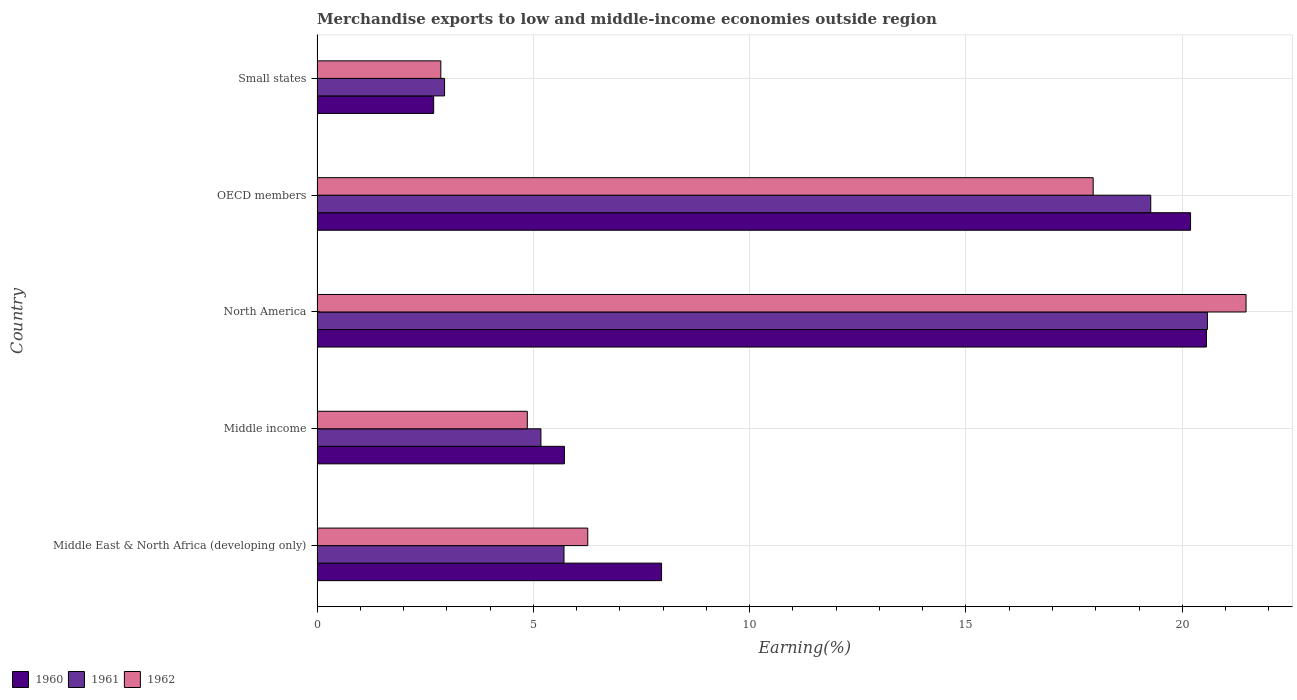How many different coloured bars are there?
Keep it short and to the point. 3. How many bars are there on the 3rd tick from the bottom?
Give a very brief answer. 3. What is the label of the 5th group of bars from the top?
Provide a short and direct response. Middle East & North Africa (developing only). In how many cases, is the number of bars for a given country not equal to the number of legend labels?
Offer a terse response. 0. What is the percentage of amount earned from merchandise exports in 1961 in Middle East & North Africa (developing only)?
Give a very brief answer. 5.71. Across all countries, what is the maximum percentage of amount earned from merchandise exports in 1961?
Your response must be concise. 20.58. Across all countries, what is the minimum percentage of amount earned from merchandise exports in 1962?
Make the answer very short. 2.86. In which country was the percentage of amount earned from merchandise exports in 1962 minimum?
Provide a succinct answer. Small states. What is the total percentage of amount earned from merchandise exports in 1960 in the graph?
Your response must be concise. 57.13. What is the difference between the percentage of amount earned from merchandise exports in 1961 in OECD members and that in Small states?
Your response must be concise. 16.32. What is the difference between the percentage of amount earned from merchandise exports in 1961 in Middle income and the percentage of amount earned from merchandise exports in 1962 in OECD members?
Keep it short and to the point. -12.77. What is the average percentage of amount earned from merchandise exports in 1962 per country?
Give a very brief answer. 10.68. What is the difference between the percentage of amount earned from merchandise exports in 1960 and percentage of amount earned from merchandise exports in 1961 in Middle East & North Africa (developing only)?
Make the answer very short. 2.26. What is the ratio of the percentage of amount earned from merchandise exports in 1962 in Middle East & North Africa (developing only) to that in OECD members?
Make the answer very short. 0.35. Is the percentage of amount earned from merchandise exports in 1960 in North America less than that in OECD members?
Make the answer very short. No. What is the difference between the highest and the second highest percentage of amount earned from merchandise exports in 1961?
Make the answer very short. 1.31. What is the difference between the highest and the lowest percentage of amount earned from merchandise exports in 1961?
Your answer should be very brief. 17.63. In how many countries, is the percentage of amount earned from merchandise exports in 1961 greater than the average percentage of amount earned from merchandise exports in 1961 taken over all countries?
Your answer should be very brief. 2. Is it the case that in every country, the sum of the percentage of amount earned from merchandise exports in 1960 and percentage of amount earned from merchandise exports in 1961 is greater than the percentage of amount earned from merchandise exports in 1962?
Keep it short and to the point. Yes. How many countries are there in the graph?
Ensure brevity in your answer.  5. What is the difference between two consecutive major ticks on the X-axis?
Your answer should be very brief. 5. Where does the legend appear in the graph?
Keep it short and to the point. Bottom left. What is the title of the graph?
Ensure brevity in your answer.  Merchandise exports to low and middle-income economies outside region. Does "2013" appear as one of the legend labels in the graph?
Offer a terse response. No. What is the label or title of the X-axis?
Ensure brevity in your answer.  Earning(%). What is the Earning(%) of 1960 in Middle East & North Africa (developing only)?
Offer a terse response. 7.96. What is the Earning(%) of 1961 in Middle East & North Africa (developing only)?
Give a very brief answer. 5.71. What is the Earning(%) in 1962 in Middle East & North Africa (developing only)?
Your answer should be compact. 6.26. What is the Earning(%) in 1960 in Middle income?
Your response must be concise. 5.72. What is the Earning(%) in 1961 in Middle income?
Offer a terse response. 5.17. What is the Earning(%) in 1962 in Middle income?
Offer a terse response. 4.86. What is the Earning(%) of 1960 in North America?
Give a very brief answer. 20.56. What is the Earning(%) in 1961 in North America?
Your answer should be compact. 20.58. What is the Earning(%) in 1962 in North America?
Keep it short and to the point. 21.47. What is the Earning(%) of 1960 in OECD members?
Your answer should be compact. 20.19. What is the Earning(%) of 1961 in OECD members?
Make the answer very short. 19.27. What is the Earning(%) of 1962 in OECD members?
Your answer should be very brief. 17.94. What is the Earning(%) of 1960 in Small states?
Your answer should be compact. 2.7. What is the Earning(%) of 1961 in Small states?
Offer a terse response. 2.95. What is the Earning(%) in 1962 in Small states?
Offer a very short reply. 2.86. Across all countries, what is the maximum Earning(%) in 1960?
Offer a very short reply. 20.56. Across all countries, what is the maximum Earning(%) in 1961?
Keep it short and to the point. 20.58. Across all countries, what is the maximum Earning(%) in 1962?
Offer a very short reply. 21.47. Across all countries, what is the minimum Earning(%) of 1960?
Offer a terse response. 2.7. Across all countries, what is the minimum Earning(%) of 1961?
Provide a succinct answer. 2.95. Across all countries, what is the minimum Earning(%) of 1962?
Keep it short and to the point. 2.86. What is the total Earning(%) of 1960 in the graph?
Your response must be concise. 57.13. What is the total Earning(%) of 1961 in the graph?
Keep it short and to the point. 53.68. What is the total Earning(%) of 1962 in the graph?
Your answer should be very brief. 53.39. What is the difference between the Earning(%) of 1960 in Middle East & North Africa (developing only) and that in Middle income?
Make the answer very short. 2.25. What is the difference between the Earning(%) of 1961 in Middle East & North Africa (developing only) and that in Middle income?
Your response must be concise. 0.53. What is the difference between the Earning(%) of 1962 in Middle East & North Africa (developing only) and that in Middle income?
Your answer should be very brief. 1.4. What is the difference between the Earning(%) in 1960 in Middle East & North Africa (developing only) and that in North America?
Offer a very short reply. -12.59. What is the difference between the Earning(%) of 1961 in Middle East & North Africa (developing only) and that in North America?
Give a very brief answer. -14.87. What is the difference between the Earning(%) in 1962 in Middle East & North Africa (developing only) and that in North America?
Ensure brevity in your answer.  -15.22. What is the difference between the Earning(%) of 1960 in Middle East & North Africa (developing only) and that in OECD members?
Keep it short and to the point. -12.23. What is the difference between the Earning(%) of 1961 in Middle East & North Africa (developing only) and that in OECD members?
Provide a short and direct response. -13.56. What is the difference between the Earning(%) in 1962 in Middle East & North Africa (developing only) and that in OECD members?
Provide a short and direct response. -11.68. What is the difference between the Earning(%) in 1960 in Middle East & North Africa (developing only) and that in Small states?
Offer a terse response. 5.27. What is the difference between the Earning(%) of 1961 in Middle East & North Africa (developing only) and that in Small states?
Give a very brief answer. 2.76. What is the difference between the Earning(%) of 1962 in Middle East & North Africa (developing only) and that in Small states?
Keep it short and to the point. 3.4. What is the difference between the Earning(%) in 1960 in Middle income and that in North America?
Provide a short and direct response. -14.84. What is the difference between the Earning(%) in 1961 in Middle income and that in North America?
Make the answer very short. -15.41. What is the difference between the Earning(%) of 1962 in Middle income and that in North America?
Ensure brevity in your answer.  -16.61. What is the difference between the Earning(%) of 1960 in Middle income and that in OECD members?
Provide a short and direct response. -14.47. What is the difference between the Earning(%) of 1961 in Middle income and that in OECD members?
Offer a very short reply. -14.1. What is the difference between the Earning(%) of 1962 in Middle income and that in OECD members?
Keep it short and to the point. -13.08. What is the difference between the Earning(%) of 1960 in Middle income and that in Small states?
Offer a very short reply. 3.02. What is the difference between the Earning(%) of 1961 in Middle income and that in Small states?
Give a very brief answer. 2.23. What is the difference between the Earning(%) of 1962 in Middle income and that in Small states?
Offer a terse response. 2. What is the difference between the Earning(%) of 1960 in North America and that in OECD members?
Offer a very short reply. 0.37. What is the difference between the Earning(%) of 1961 in North America and that in OECD members?
Your response must be concise. 1.31. What is the difference between the Earning(%) in 1962 in North America and that in OECD members?
Give a very brief answer. 3.53. What is the difference between the Earning(%) of 1960 in North America and that in Small states?
Provide a succinct answer. 17.86. What is the difference between the Earning(%) of 1961 in North America and that in Small states?
Your response must be concise. 17.63. What is the difference between the Earning(%) in 1962 in North America and that in Small states?
Offer a terse response. 18.61. What is the difference between the Earning(%) of 1960 in OECD members and that in Small states?
Offer a terse response. 17.5. What is the difference between the Earning(%) in 1961 in OECD members and that in Small states?
Make the answer very short. 16.32. What is the difference between the Earning(%) in 1962 in OECD members and that in Small states?
Provide a succinct answer. 15.08. What is the difference between the Earning(%) of 1960 in Middle East & North Africa (developing only) and the Earning(%) of 1961 in Middle income?
Make the answer very short. 2.79. What is the difference between the Earning(%) of 1960 in Middle East & North Africa (developing only) and the Earning(%) of 1962 in Middle income?
Your answer should be very brief. 3.1. What is the difference between the Earning(%) of 1961 in Middle East & North Africa (developing only) and the Earning(%) of 1962 in Middle income?
Give a very brief answer. 0.85. What is the difference between the Earning(%) of 1960 in Middle East & North Africa (developing only) and the Earning(%) of 1961 in North America?
Your answer should be compact. -12.62. What is the difference between the Earning(%) in 1960 in Middle East & North Africa (developing only) and the Earning(%) in 1962 in North America?
Provide a succinct answer. -13.51. What is the difference between the Earning(%) of 1961 in Middle East & North Africa (developing only) and the Earning(%) of 1962 in North America?
Offer a terse response. -15.77. What is the difference between the Earning(%) of 1960 in Middle East & North Africa (developing only) and the Earning(%) of 1961 in OECD members?
Provide a short and direct response. -11.31. What is the difference between the Earning(%) of 1960 in Middle East & North Africa (developing only) and the Earning(%) of 1962 in OECD members?
Offer a very short reply. -9.98. What is the difference between the Earning(%) of 1961 in Middle East & North Africa (developing only) and the Earning(%) of 1962 in OECD members?
Provide a short and direct response. -12.23. What is the difference between the Earning(%) of 1960 in Middle East & North Africa (developing only) and the Earning(%) of 1961 in Small states?
Make the answer very short. 5.02. What is the difference between the Earning(%) of 1960 in Middle East & North Africa (developing only) and the Earning(%) of 1962 in Small states?
Give a very brief answer. 5.1. What is the difference between the Earning(%) in 1961 in Middle East & North Africa (developing only) and the Earning(%) in 1962 in Small states?
Your answer should be compact. 2.85. What is the difference between the Earning(%) of 1960 in Middle income and the Earning(%) of 1961 in North America?
Ensure brevity in your answer.  -14.86. What is the difference between the Earning(%) of 1960 in Middle income and the Earning(%) of 1962 in North America?
Make the answer very short. -15.76. What is the difference between the Earning(%) of 1961 in Middle income and the Earning(%) of 1962 in North America?
Ensure brevity in your answer.  -16.3. What is the difference between the Earning(%) of 1960 in Middle income and the Earning(%) of 1961 in OECD members?
Ensure brevity in your answer.  -13.55. What is the difference between the Earning(%) of 1960 in Middle income and the Earning(%) of 1962 in OECD members?
Your answer should be compact. -12.22. What is the difference between the Earning(%) of 1961 in Middle income and the Earning(%) of 1962 in OECD members?
Your answer should be compact. -12.77. What is the difference between the Earning(%) in 1960 in Middle income and the Earning(%) in 1961 in Small states?
Offer a terse response. 2.77. What is the difference between the Earning(%) of 1960 in Middle income and the Earning(%) of 1962 in Small states?
Give a very brief answer. 2.86. What is the difference between the Earning(%) of 1961 in Middle income and the Earning(%) of 1962 in Small states?
Your response must be concise. 2.31. What is the difference between the Earning(%) of 1960 in North America and the Earning(%) of 1961 in OECD members?
Give a very brief answer. 1.29. What is the difference between the Earning(%) of 1960 in North America and the Earning(%) of 1962 in OECD members?
Provide a short and direct response. 2.62. What is the difference between the Earning(%) of 1961 in North America and the Earning(%) of 1962 in OECD members?
Ensure brevity in your answer.  2.64. What is the difference between the Earning(%) in 1960 in North America and the Earning(%) in 1961 in Small states?
Keep it short and to the point. 17.61. What is the difference between the Earning(%) of 1960 in North America and the Earning(%) of 1962 in Small states?
Give a very brief answer. 17.7. What is the difference between the Earning(%) of 1961 in North America and the Earning(%) of 1962 in Small states?
Offer a terse response. 17.72. What is the difference between the Earning(%) in 1960 in OECD members and the Earning(%) in 1961 in Small states?
Your response must be concise. 17.24. What is the difference between the Earning(%) of 1960 in OECD members and the Earning(%) of 1962 in Small states?
Your answer should be very brief. 17.33. What is the difference between the Earning(%) in 1961 in OECD members and the Earning(%) in 1962 in Small states?
Provide a short and direct response. 16.41. What is the average Earning(%) in 1960 per country?
Give a very brief answer. 11.43. What is the average Earning(%) of 1961 per country?
Offer a terse response. 10.74. What is the average Earning(%) in 1962 per country?
Your response must be concise. 10.68. What is the difference between the Earning(%) in 1960 and Earning(%) in 1961 in Middle East & North Africa (developing only)?
Provide a succinct answer. 2.26. What is the difference between the Earning(%) of 1960 and Earning(%) of 1962 in Middle East & North Africa (developing only)?
Keep it short and to the point. 1.71. What is the difference between the Earning(%) in 1961 and Earning(%) in 1962 in Middle East & North Africa (developing only)?
Ensure brevity in your answer.  -0.55. What is the difference between the Earning(%) of 1960 and Earning(%) of 1961 in Middle income?
Ensure brevity in your answer.  0.54. What is the difference between the Earning(%) of 1960 and Earning(%) of 1962 in Middle income?
Provide a succinct answer. 0.86. What is the difference between the Earning(%) in 1961 and Earning(%) in 1962 in Middle income?
Your answer should be very brief. 0.31. What is the difference between the Earning(%) of 1960 and Earning(%) of 1961 in North America?
Your response must be concise. -0.02. What is the difference between the Earning(%) of 1960 and Earning(%) of 1962 in North America?
Offer a terse response. -0.92. What is the difference between the Earning(%) of 1961 and Earning(%) of 1962 in North America?
Your answer should be very brief. -0.89. What is the difference between the Earning(%) in 1960 and Earning(%) in 1961 in OECD members?
Make the answer very short. 0.92. What is the difference between the Earning(%) of 1960 and Earning(%) of 1962 in OECD members?
Provide a short and direct response. 2.25. What is the difference between the Earning(%) in 1961 and Earning(%) in 1962 in OECD members?
Provide a short and direct response. 1.33. What is the difference between the Earning(%) in 1960 and Earning(%) in 1961 in Small states?
Offer a very short reply. -0.25. What is the difference between the Earning(%) of 1960 and Earning(%) of 1962 in Small states?
Provide a short and direct response. -0.17. What is the difference between the Earning(%) in 1961 and Earning(%) in 1962 in Small states?
Your answer should be very brief. 0.09. What is the ratio of the Earning(%) in 1960 in Middle East & North Africa (developing only) to that in Middle income?
Ensure brevity in your answer.  1.39. What is the ratio of the Earning(%) of 1961 in Middle East & North Africa (developing only) to that in Middle income?
Ensure brevity in your answer.  1.1. What is the ratio of the Earning(%) in 1962 in Middle East & North Africa (developing only) to that in Middle income?
Offer a very short reply. 1.29. What is the ratio of the Earning(%) of 1960 in Middle East & North Africa (developing only) to that in North America?
Keep it short and to the point. 0.39. What is the ratio of the Earning(%) in 1961 in Middle East & North Africa (developing only) to that in North America?
Your response must be concise. 0.28. What is the ratio of the Earning(%) in 1962 in Middle East & North Africa (developing only) to that in North America?
Offer a very short reply. 0.29. What is the ratio of the Earning(%) in 1960 in Middle East & North Africa (developing only) to that in OECD members?
Give a very brief answer. 0.39. What is the ratio of the Earning(%) in 1961 in Middle East & North Africa (developing only) to that in OECD members?
Offer a terse response. 0.3. What is the ratio of the Earning(%) in 1962 in Middle East & North Africa (developing only) to that in OECD members?
Keep it short and to the point. 0.35. What is the ratio of the Earning(%) of 1960 in Middle East & North Africa (developing only) to that in Small states?
Provide a succinct answer. 2.95. What is the ratio of the Earning(%) in 1961 in Middle East & North Africa (developing only) to that in Small states?
Make the answer very short. 1.94. What is the ratio of the Earning(%) of 1962 in Middle East & North Africa (developing only) to that in Small states?
Your response must be concise. 2.19. What is the ratio of the Earning(%) of 1960 in Middle income to that in North America?
Your answer should be compact. 0.28. What is the ratio of the Earning(%) in 1961 in Middle income to that in North America?
Your answer should be very brief. 0.25. What is the ratio of the Earning(%) in 1962 in Middle income to that in North America?
Your response must be concise. 0.23. What is the ratio of the Earning(%) in 1960 in Middle income to that in OECD members?
Ensure brevity in your answer.  0.28. What is the ratio of the Earning(%) in 1961 in Middle income to that in OECD members?
Provide a short and direct response. 0.27. What is the ratio of the Earning(%) of 1962 in Middle income to that in OECD members?
Offer a terse response. 0.27. What is the ratio of the Earning(%) of 1960 in Middle income to that in Small states?
Offer a terse response. 2.12. What is the ratio of the Earning(%) of 1961 in Middle income to that in Small states?
Keep it short and to the point. 1.76. What is the ratio of the Earning(%) in 1962 in Middle income to that in Small states?
Your answer should be compact. 1.7. What is the ratio of the Earning(%) of 1960 in North America to that in OECD members?
Give a very brief answer. 1.02. What is the ratio of the Earning(%) in 1961 in North America to that in OECD members?
Ensure brevity in your answer.  1.07. What is the ratio of the Earning(%) in 1962 in North America to that in OECD members?
Your answer should be compact. 1.2. What is the ratio of the Earning(%) in 1960 in North America to that in Small states?
Offer a terse response. 7.63. What is the ratio of the Earning(%) in 1961 in North America to that in Small states?
Your answer should be very brief. 6.98. What is the ratio of the Earning(%) of 1962 in North America to that in Small states?
Make the answer very short. 7.51. What is the ratio of the Earning(%) in 1960 in OECD members to that in Small states?
Offer a very short reply. 7.49. What is the ratio of the Earning(%) in 1961 in OECD members to that in Small states?
Offer a terse response. 6.54. What is the ratio of the Earning(%) in 1962 in OECD members to that in Small states?
Make the answer very short. 6.27. What is the difference between the highest and the second highest Earning(%) in 1960?
Your response must be concise. 0.37. What is the difference between the highest and the second highest Earning(%) of 1961?
Your answer should be compact. 1.31. What is the difference between the highest and the second highest Earning(%) of 1962?
Provide a succinct answer. 3.53. What is the difference between the highest and the lowest Earning(%) of 1960?
Give a very brief answer. 17.86. What is the difference between the highest and the lowest Earning(%) in 1961?
Your answer should be compact. 17.63. What is the difference between the highest and the lowest Earning(%) of 1962?
Your answer should be compact. 18.61. 